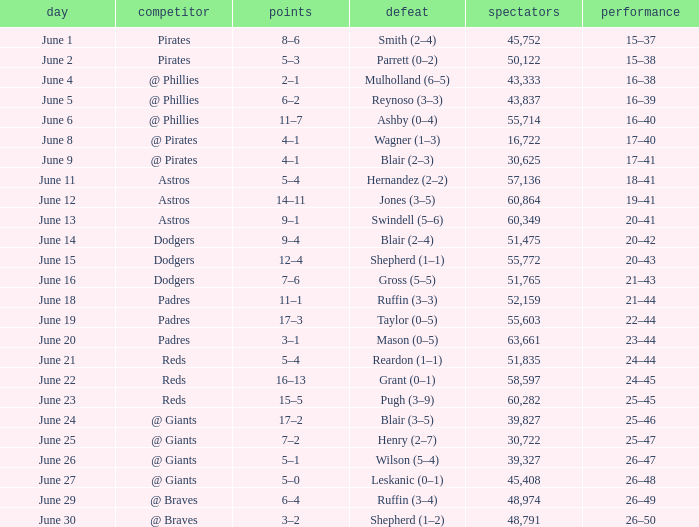Write the full table. {'header': ['day', 'competitor', 'points', 'defeat', 'spectators', 'performance'], 'rows': [['June 1', 'Pirates', '8–6', 'Smith (2–4)', '45,752', '15–37'], ['June 2', 'Pirates', '5–3', 'Parrett (0–2)', '50,122', '15–38'], ['June 4', '@ Phillies', '2–1', 'Mulholland (6–5)', '43,333', '16–38'], ['June 5', '@ Phillies', '6–2', 'Reynoso (3–3)', '43,837', '16–39'], ['June 6', '@ Phillies', '11–7', 'Ashby (0–4)', '55,714', '16–40'], ['June 8', '@ Pirates', '4–1', 'Wagner (1–3)', '16,722', '17–40'], ['June 9', '@ Pirates', '4–1', 'Blair (2–3)', '30,625', '17–41'], ['June 11', 'Astros', '5–4', 'Hernandez (2–2)', '57,136', '18–41'], ['June 12', 'Astros', '14–11', 'Jones (3–5)', '60,864', '19–41'], ['June 13', 'Astros', '9–1', 'Swindell (5–6)', '60,349', '20–41'], ['June 14', 'Dodgers', '9–4', 'Blair (2–4)', '51,475', '20–42'], ['June 15', 'Dodgers', '12–4', 'Shepherd (1–1)', '55,772', '20–43'], ['June 16', 'Dodgers', '7–6', 'Gross (5–5)', '51,765', '21–43'], ['June 18', 'Padres', '11–1', 'Ruffin (3–3)', '52,159', '21–44'], ['June 19', 'Padres', '17–3', 'Taylor (0–5)', '55,603', '22–44'], ['June 20', 'Padres', '3–1', 'Mason (0–5)', '63,661', '23–44'], ['June 21', 'Reds', '5–4', 'Reardon (1–1)', '51,835', '24–44'], ['June 22', 'Reds', '16–13', 'Grant (0–1)', '58,597', '24–45'], ['June 23', 'Reds', '15–5', 'Pugh (3–9)', '60,282', '25–45'], ['June 24', '@ Giants', '17–2', 'Blair (3–5)', '39,827', '25–46'], ['June 25', '@ Giants', '7–2', 'Henry (2–7)', '30,722', '25–47'], ['June 26', '@ Giants', '5–1', 'Wilson (5–4)', '39,327', '26–47'], ['June 27', '@ Giants', '5–0', 'Leskanic (0–1)', '45,408', '26–48'], ['June 29', '@ Braves', '6–4', 'Ruffin (3–4)', '48,974', '26–49'], ['June 30', '@ Braves', '3–2', 'Shepherd (1–2)', '48,791', '26–50']]} What was the score on June 12? 14–11. 